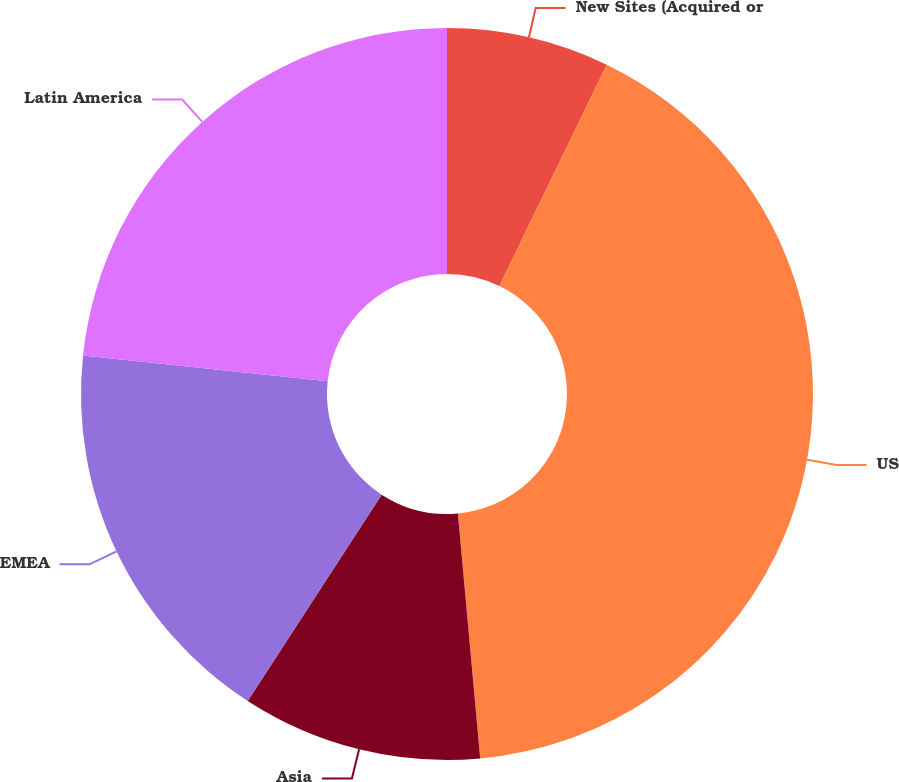Convert chart. <chart><loc_0><loc_0><loc_500><loc_500><pie_chart><fcel>New Sites (Acquired or<fcel>US<fcel>Asia<fcel>EMEA<fcel>Latin America<nl><fcel>7.19%<fcel>41.37%<fcel>10.61%<fcel>17.52%<fcel>23.32%<nl></chart> 